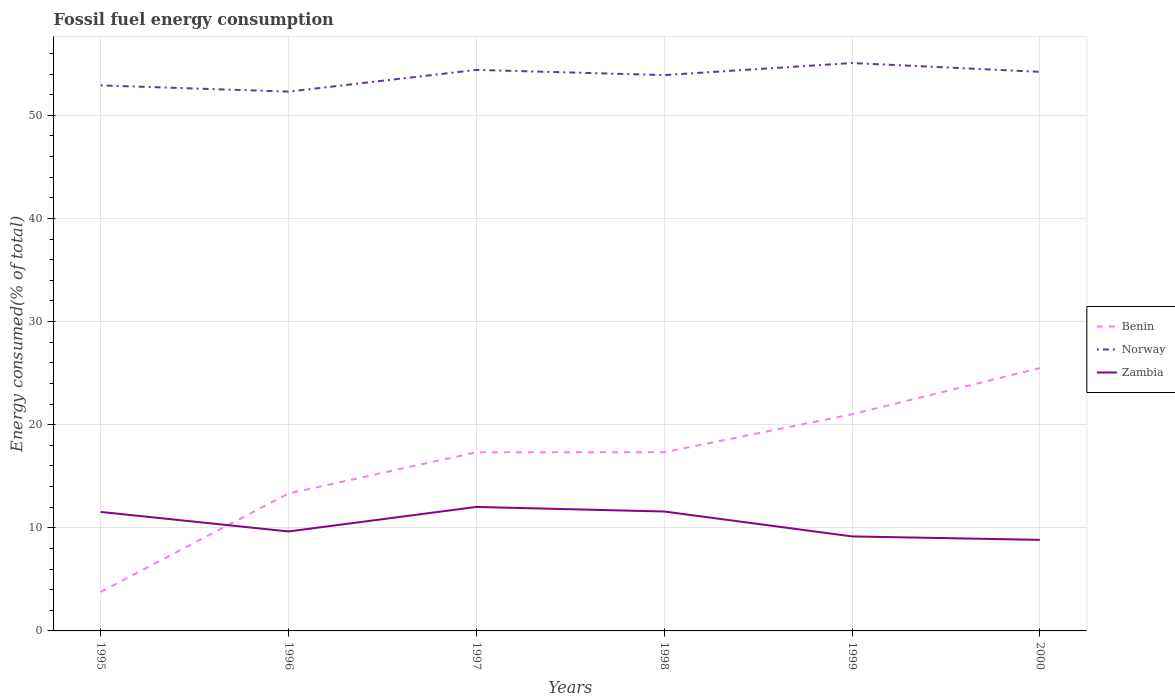Does the line corresponding to Zambia intersect with the line corresponding to Benin?
Make the answer very short. Yes. Is the number of lines equal to the number of legend labels?
Offer a terse response. Yes. Across all years, what is the maximum percentage of energy consumed in Zambia?
Provide a succinct answer. 8.83. In which year was the percentage of energy consumed in Zambia maximum?
Ensure brevity in your answer.  2000. What is the total percentage of energy consumed in Norway in the graph?
Offer a very short reply. 0.6. What is the difference between the highest and the second highest percentage of energy consumed in Norway?
Ensure brevity in your answer.  2.77. What is the difference between the highest and the lowest percentage of energy consumed in Norway?
Your response must be concise. 4. How many lines are there?
Provide a succinct answer. 3. What is the difference between two consecutive major ticks on the Y-axis?
Ensure brevity in your answer.  10. Are the values on the major ticks of Y-axis written in scientific E-notation?
Ensure brevity in your answer.  No. Does the graph contain grids?
Ensure brevity in your answer.  Yes. How many legend labels are there?
Your response must be concise. 3. How are the legend labels stacked?
Keep it short and to the point. Vertical. What is the title of the graph?
Ensure brevity in your answer.  Fossil fuel energy consumption. Does "United Kingdom" appear as one of the legend labels in the graph?
Your answer should be compact. No. What is the label or title of the Y-axis?
Make the answer very short. Energy consumed(% of total). What is the Energy consumed(% of total) of Benin in 1995?
Provide a succinct answer. 3.78. What is the Energy consumed(% of total) in Norway in 1995?
Provide a succinct answer. 52.9. What is the Energy consumed(% of total) in Zambia in 1995?
Give a very brief answer. 11.54. What is the Energy consumed(% of total) of Benin in 1996?
Provide a succinct answer. 13.33. What is the Energy consumed(% of total) in Norway in 1996?
Make the answer very short. 52.3. What is the Energy consumed(% of total) in Zambia in 1996?
Keep it short and to the point. 9.65. What is the Energy consumed(% of total) in Benin in 1997?
Provide a succinct answer. 17.32. What is the Energy consumed(% of total) in Norway in 1997?
Offer a terse response. 54.4. What is the Energy consumed(% of total) in Zambia in 1997?
Provide a succinct answer. 12.02. What is the Energy consumed(% of total) in Benin in 1998?
Provide a short and direct response. 17.33. What is the Energy consumed(% of total) in Norway in 1998?
Keep it short and to the point. 53.9. What is the Energy consumed(% of total) in Zambia in 1998?
Make the answer very short. 11.58. What is the Energy consumed(% of total) in Benin in 1999?
Offer a terse response. 21.01. What is the Energy consumed(% of total) of Norway in 1999?
Offer a terse response. 55.07. What is the Energy consumed(% of total) of Zambia in 1999?
Provide a succinct answer. 9.16. What is the Energy consumed(% of total) in Benin in 2000?
Provide a succinct answer. 25.49. What is the Energy consumed(% of total) in Norway in 2000?
Make the answer very short. 54.22. What is the Energy consumed(% of total) of Zambia in 2000?
Give a very brief answer. 8.83. Across all years, what is the maximum Energy consumed(% of total) in Benin?
Keep it short and to the point. 25.49. Across all years, what is the maximum Energy consumed(% of total) in Norway?
Your answer should be very brief. 55.07. Across all years, what is the maximum Energy consumed(% of total) of Zambia?
Provide a succinct answer. 12.02. Across all years, what is the minimum Energy consumed(% of total) in Benin?
Give a very brief answer. 3.78. Across all years, what is the minimum Energy consumed(% of total) of Norway?
Ensure brevity in your answer.  52.3. Across all years, what is the minimum Energy consumed(% of total) in Zambia?
Give a very brief answer. 8.83. What is the total Energy consumed(% of total) in Benin in the graph?
Make the answer very short. 98.26. What is the total Energy consumed(% of total) of Norway in the graph?
Your answer should be very brief. 322.79. What is the total Energy consumed(% of total) of Zambia in the graph?
Provide a succinct answer. 62.78. What is the difference between the Energy consumed(% of total) in Benin in 1995 and that in 1996?
Your response must be concise. -9.55. What is the difference between the Energy consumed(% of total) of Norway in 1995 and that in 1996?
Provide a succinct answer. 0.6. What is the difference between the Energy consumed(% of total) of Zambia in 1995 and that in 1996?
Your response must be concise. 1.89. What is the difference between the Energy consumed(% of total) of Benin in 1995 and that in 1997?
Your answer should be compact. -13.54. What is the difference between the Energy consumed(% of total) of Norway in 1995 and that in 1997?
Your response must be concise. -1.5. What is the difference between the Energy consumed(% of total) of Zambia in 1995 and that in 1997?
Your answer should be compact. -0.48. What is the difference between the Energy consumed(% of total) in Benin in 1995 and that in 1998?
Make the answer very short. -13.55. What is the difference between the Energy consumed(% of total) of Norway in 1995 and that in 1998?
Your answer should be very brief. -1. What is the difference between the Energy consumed(% of total) of Zambia in 1995 and that in 1998?
Offer a very short reply. -0.04. What is the difference between the Energy consumed(% of total) of Benin in 1995 and that in 1999?
Make the answer very short. -17.23. What is the difference between the Energy consumed(% of total) of Norway in 1995 and that in 1999?
Offer a very short reply. -2.17. What is the difference between the Energy consumed(% of total) in Zambia in 1995 and that in 1999?
Offer a very short reply. 2.37. What is the difference between the Energy consumed(% of total) in Benin in 1995 and that in 2000?
Your answer should be compact. -21.71. What is the difference between the Energy consumed(% of total) of Norway in 1995 and that in 2000?
Provide a succinct answer. -1.31. What is the difference between the Energy consumed(% of total) of Zambia in 1995 and that in 2000?
Offer a terse response. 2.71. What is the difference between the Energy consumed(% of total) of Benin in 1996 and that in 1997?
Provide a succinct answer. -3.99. What is the difference between the Energy consumed(% of total) of Norway in 1996 and that in 1997?
Your response must be concise. -2.11. What is the difference between the Energy consumed(% of total) in Zambia in 1996 and that in 1997?
Provide a succinct answer. -2.38. What is the difference between the Energy consumed(% of total) of Benin in 1996 and that in 1998?
Ensure brevity in your answer.  -4. What is the difference between the Energy consumed(% of total) in Norway in 1996 and that in 1998?
Your answer should be very brief. -1.6. What is the difference between the Energy consumed(% of total) of Zambia in 1996 and that in 1998?
Your answer should be compact. -1.93. What is the difference between the Energy consumed(% of total) of Benin in 1996 and that in 1999?
Offer a very short reply. -7.68. What is the difference between the Energy consumed(% of total) in Norway in 1996 and that in 1999?
Offer a very short reply. -2.77. What is the difference between the Energy consumed(% of total) of Zambia in 1996 and that in 1999?
Your response must be concise. 0.48. What is the difference between the Energy consumed(% of total) in Benin in 1996 and that in 2000?
Offer a terse response. -12.15. What is the difference between the Energy consumed(% of total) in Norway in 1996 and that in 2000?
Give a very brief answer. -1.92. What is the difference between the Energy consumed(% of total) in Zambia in 1996 and that in 2000?
Provide a short and direct response. 0.81. What is the difference between the Energy consumed(% of total) of Benin in 1997 and that in 1998?
Keep it short and to the point. -0.01. What is the difference between the Energy consumed(% of total) in Norway in 1997 and that in 1998?
Your response must be concise. 0.5. What is the difference between the Energy consumed(% of total) in Zambia in 1997 and that in 1998?
Your answer should be compact. 0.44. What is the difference between the Energy consumed(% of total) of Benin in 1997 and that in 1999?
Keep it short and to the point. -3.69. What is the difference between the Energy consumed(% of total) in Norway in 1997 and that in 1999?
Offer a terse response. -0.67. What is the difference between the Energy consumed(% of total) in Zambia in 1997 and that in 1999?
Make the answer very short. 2.86. What is the difference between the Energy consumed(% of total) of Benin in 1997 and that in 2000?
Give a very brief answer. -8.16. What is the difference between the Energy consumed(% of total) in Norway in 1997 and that in 2000?
Provide a succinct answer. 0.19. What is the difference between the Energy consumed(% of total) in Zambia in 1997 and that in 2000?
Your response must be concise. 3.19. What is the difference between the Energy consumed(% of total) in Benin in 1998 and that in 1999?
Provide a succinct answer. -3.68. What is the difference between the Energy consumed(% of total) in Norway in 1998 and that in 1999?
Give a very brief answer. -1.17. What is the difference between the Energy consumed(% of total) in Zambia in 1998 and that in 1999?
Your response must be concise. 2.41. What is the difference between the Energy consumed(% of total) of Benin in 1998 and that in 2000?
Your response must be concise. -8.16. What is the difference between the Energy consumed(% of total) in Norway in 1998 and that in 2000?
Offer a very short reply. -0.31. What is the difference between the Energy consumed(% of total) in Zambia in 1998 and that in 2000?
Offer a very short reply. 2.75. What is the difference between the Energy consumed(% of total) of Benin in 1999 and that in 2000?
Provide a succinct answer. -4.48. What is the difference between the Energy consumed(% of total) of Norway in 1999 and that in 2000?
Your answer should be compact. 0.85. What is the difference between the Energy consumed(% of total) of Zambia in 1999 and that in 2000?
Make the answer very short. 0.33. What is the difference between the Energy consumed(% of total) in Benin in 1995 and the Energy consumed(% of total) in Norway in 1996?
Your response must be concise. -48.52. What is the difference between the Energy consumed(% of total) in Benin in 1995 and the Energy consumed(% of total) in Zambia in 1996?
Your answer should be compact. -5.86. What is the difference between the Energy consumed(% of total) of Norway in 1995 and the Energy consumed(% of total) of Zambia in 1996?
Ensure brevity in your answer.  43.26. What is the difference between the Energy consumed(% of total) of Benin in 1995 and the Energy consumed(% of total) of Norway in 1997?
Provide a short and direct response. -50.62. What is the difference between the Energy consumed(% of total) in Benin in 1995 and the Energy consumed(% of total) in Zambia in 1997?
Provide a succinct answer. -8.24. What is the difference between the Energy consumed(% of total) in Norway in 1995 and the Energy consumed(% of total) in Zambia in 1997?
Ensure brevity in your answer.  40.88. What is the difference between the Energy consumed(% of total) of Benin in 1995 and the Energy consumed(% of total) of Norway in 1998?
Keep it short and to the point. -50.12. What is the difference between the Energy consumed(% of total) of Benin in 1995 and the Energy consumed(% of total) of Zambia in 1998?
Your answer should be very brief. -7.8. What is the difference between the Energy consumed(% of total) of Norway in 1995 and the Energy consumed(% of total) of Zambia in 1998?
Your answer should be compact. 41.32. What is the difference between the Energy consumed(% of total) in Benin in 1995 and the Energy consumed(% of total) in Norway in 1999?
Your answer should be very brief. -51.29. What is the difference between the Energy consumed(% of total) in Benin in 1995 and the Energy consumed(% of total) in Zambia in 1999?
Your response must be concise. -5.38. What is the difference between the Energy consumed(% of total) in Norway in 1995 and the Energy consumed(% of total) in Zambia in 1999?
Offer a terse response. 43.74. What is the difference between the Energy consumed(% of total) of Benin in 1995 and the Energy consumed(% of total) of Norway in 2000?
Offer a very short reply. -50.44. What is the difference between the Energy consumed(% of total) of Benin in 1995 and the Energy consumed(% of total) of Zambia in 2000?
Give a very brief answer. -5.05. What is the difference between the Energy consumed(% of total) in Norway in 1995 and the Energy consumed(% of total) in Zambia in 2000?
Your answer should be compact. 44.07. What is the difference between the Energy consumed(% of total) in Benin in 1996 and the Energy consumed(% of total) in Norway in 1997?
Make the answer very short. -41.07. What is the difference between the Energy consumed(% of total) of Benin in 1996 and the Energy consumed(% of total) of Zambia in 1997?
Offer a very short reply. 1.31. What is the difference between the Energy consumed(% of total) in Norway in 1996 and the Energy consumed(% of total) in Zambia in 1997?
Ensure brevity in your answer.  40.28. What is the difference between the Energy consumed(% of total) of Benin in 1996 and the Energy consumed(% of total) of Norway in 1998?
Your answer should be very brief. -40.57. What is the difference between the Energy consumed(% of total) in Benin in 1996 and the Energy consumed(% of total) in Zambia in 1998?
Your answer should be very brief. 1.75. What is the difference between the Energy consumed(% of total) in Norway in 1996 and the Energy consumed(% of total) in Zambia in 1998?
Make the answer very short. 40.72. What is the difference between the Energy consumed(% of total) of Benin in 1996 and the Energy consumed(% of total) of Norway in 1999?
Make the answer very short. -41.74. What is the difference between the Energy consumed(% of total) of Benin in 1996 and the Energy consumed(% of total) of Zambia in 1999?
Keep it short and to the point. 4.17. What is the difference between the Energy consumed(% of total) of Norway in 1996 and the Energy consumed(% of total) of Zambia in 1999?
Your answer should be very brief. 43.13. What is the difference between the Energy consumed(% of total) in Benin in 1996 and the Energy consumed(% of total) in Norway in 2000?
Your answer should be very brief. -40.88. What is the difference between the Energy consumed(% of total) in Benin in 1996 and the Energy consumed(% of total) in Zambia in 2000?
Your response must be concise. 4.5. What is the difference between the Energy consumed(% of total) in Norway in 1996 and the Energy consumed(% of total) in Zambia in 2000?
Your answer should be compact. 43.47. What is the difference between the Energy consumed(% of total) of Benin in 1997 and the Energy consumed(% of total) of Norway in 1998?
Make the answer very short. -36.58. What is the difference between the Energy consumed(% of total) of Benin in 1997 and the Energy consumed(% of total) of Zambia in 1998?
Your answer should be compact. 5.74. What is the difference between the Energy consumed(% of total) of Norway in 1997 and the Energy consumed(% of total) of Zambia in 1998?
Ensure brevity in your answer.  42.82. What is the difference between the Energy consumed(% of total) in Benin in 1997 and the Energy consumed(% of total) in Norway in 1999?
Ensure brevity in your answer.  -37.75. What is the difference between the Energy consumed(% of total) in Benin in 1997 and the Energy consumed(% of total) in Zambia in 1999?
Your answer should be compact. 8.16. What is the difference between the Energy consumed(% of total) in Norway in 1997 and the Energy consumed(% of total) in Zambia in 1999?
Ensure brevity in your answer.  45.24. What is the difference between the Energy consumed(% of total) in Benin in 1997 and the Energy consumed(% of total) in Norway in 2000?
Provide a succinct answer. -36.89. What is the difference between the Energy consumed(% of total) of Benin in 1997 and the Energy consumed(% of total) of Zambia in 2000?
Your response must be concise. 8.49. What is the difference between the Energy consumed(% of total) in Norway in 1997 and the Energy consumed(% of total) in Zambia in 2000?
Make the answer very short. 45.57. What is the difference between the Energy consumed(% of total) of Benin in 1998 and the Energy consumed(% of total) of Norway in 1999?
Provide a succinct answer. -37.74. What is the difference between the Energy consumed(% of total) in Benin in 1998 and the Energy consumed(% of total) in Zambia in 1999?
Give a very brief answer. 8.17. What is the difference between the Energy consumed(% of total) of Norway in 1998 and the Energy consumed(% of total) of Zambia in 1999?
Your response must be concise. 44.74. What is the difference between the Energy consumed(% of total) of Benin in 1998 and the Energy consumed(% of total) of Norway in 2000?
Offer a terse response. -36.89. What is the difference between the Energy consumed(% of total) in Benin in 1998 and the Energy consumed(% of total) in Zambia in 2000?
Provide a succinct answer. 8.5. What is the difference between the Energy consumed(% of total) of Norway in 1998 and the Energy consumed(% of total) of Zambia in 2000?
Provide a short and direct response. 45.07. What is the difference between the Energy consumed(% of total) in Benin in 1999 and the Energy consumed(% of total) in Norway in 2000?
Your response must be concise. -33.21. What is the difference between the Energy consumed(% of total) of Benin in 1999 and the Energy consumed(% of total) of Zambia in 2000?
Your answer should be compact. 12.18. What is the difference between the Energy consumed(% of total) in Norway in 1999 and the Energy consumed(% of total) in Zambia in 2000?
Your response must be concise. 46.24. What is the average Energy consumed(% of total) of Benin per year?
Give a very brief answer. 16.38. What is the average Energy consumed(% of total) in Norway per year?
Provide a succinct answer. 53.8. What is the average Energy consumed(% of total) in Zambia per year?
Give a very brief answer. 10.46. In the year 1995, what is the difference between the Energy consumed(% of total) of Benin and Energy consumed(% of total) of Norway?
Your answer should be very brief. -49.12. In the year 1995, what is the difference between the Energy consumed(% of total) of Benin and Energy consumed(% of total) of Zambia?
Keep it short and to the point. -7.76. In the year 1995, what is the difference between the Energy consumed(% of total) in Norway and Energy consumed(% of total) in Zambia?
Your answer should be compact. 41.36. In the year 1996, what is the difference between the Energy consumed(% of total) in Benin and Energy consumed(% of total) in Norway?
Offer a terse response. -38.97. In the year 1996, what is the difference between the Energy consumed(% of total) in Benin and Energy consumed(% of total) in Zambia?
Ensure brevity in your answer.  3.69. In the year 1996, what is the difference between the Energy consumed(% of total) of Norway and Energy consumed(% of total) of Zambia?
Your response must be concise. 42.65. In the year 1997, what is the difference between the Energy consumed(% of total) of Benin and Energy consumed(% of total) of Norway?
Ensure brevity in your answer.  -37.08. In the year 1997, what is the difference between the Energy consumed(% of total) of Benin and Energy consumed(% of total) of Zambia?
Offer a very short reply. 5.3. In the year 1997, what is the difference between the Energy consumed(% of total) in Norway and Energy consumed(% of total) in Zambia?
Keep it short and to the point. 42.38. In the year 1998, what is the difference between the Energy consumed(% of total) of Benin and Energy consumed(% of total) of Norway?
Offer a terse response. -36.57. In the year 1998, what is the difference between the Energy consumed(% of total) of Benin and Energy consumed(% of total) of Zambia?
Your answer should be very brief. 5.75. In the year 1998, what is the difference between the Energy consumed(% of total) in Norway and Energy consumed(% of total) in Zambia?
Offer a terse response. 42.32. In the year 1999, what is the difference between the Energy consumed(% of total) of Benin and Energy consumed(% of total) of Norway?
Offer a very short reply. -34.06. In the year 1999, what is the difference between the Energy consumed(% of total) of Benin and Energy consumed(% of total) of Zambia?
Provide a succinct answer. 11.84. In the year 1999, what is the difference between the Energy consumed(% of total) in Norway and Energy consumed(% of total) in Zambia?
Your answer should be compact. 45.91. In the year 2000, what is the difference between the Energy consumed(% of total) of Benin and Energy consumed(% of total) of Norway?
Ensure brevity in your answer.  -28.73. In the year 2000, what is the difference between the Energy consumed(% of total) of Benin and Energy consumed(% of total) of Zambia?
Your response must be concise. 16.66. In the year 2000, what is the difference between the Energy consumed(% of total) in Norway and Energy consumed(% of total) in Zambia?
Your answer should be compact. 45.39. What is the ratio of the Energy consumed(% of total) of Benin in 1995 to that in 1996?
Your answer should be very brief. 0.28. What is the ratio of the Energy consumed(% of total) in Norway in 1995 to that in 1996?
Give a very brief answer. 1.01. What is the ratio of the Energy consumed(% of total) in Zambia in 1995 to that in 1996?
Give a very brief answer. 1.2. What is the ratio of the Energy consumed(% of total) in Benin in 1995 to that in 1997?
Provide a short and direct response. 0.22. What is the ratio of the Energy consumed(% of total) in Norway in 1995 to that in 1997?
Provide a succinct answer. 0.97. What is the ratio of the Energy consumed(% of total) of Zambia in 1995 to that in 1997?
Give a very brief answer. 0.96. What is the ratio of the Energy consumed(% of total) in Benin in 1995 to that in 1998?
Offer a very short reply. 0.22. What is the ratio of the Energy consumed(% of total) of Norway in 1995 to that in 1998?
Your answer should be compact. 0.98. What is the ratio of the Energy consumed(% of total) of Benin in 1995 to that in 1999?
Make the answer very short. 0.18. What is the ratio of the Energy consumed(% of total) in Norway in 1995 to that in 1999?
Provide a short and direct response. 0.96. What is the ratio of the Energy consumed(% of total) of Zambia in 1995 to that in 1999?
Your response must be concise. 1.26. What is the ratio of the Energy consumed(% of total) of Benin in 1995 to that in 2000?
Make the answer very short. 0.15. What is the ratio of the Energy consumed(% of total) of Norway in 1995 to that in 2000?
Your answer should be very brief. 0.98. What is the ratio of the Energy consumed(% of total) of Zambia in 1995 to that in 2000?
Give a very brief answer. 1.31. What is the ratio of the Energy consumed(% of total) of Benin in 1996 to that in 1997?
Offer a terse response. 0.77. What is the ratio of the Energy consumed(% of total) of Norway in 1996 to that in 1997?
Your answer should be very brief. 0.96. What is the ratio of the Energy consumed(% of total) in Zambia in 1996 to that in 1997?
Offer a terse response. 0.8. What is the ratio of the Energy consumed(% of total) of Benin in 1996 to that in 1998?
Your answer should be very brief. 0.77. What is the ratio of the Energy consumed(% of total) in Norway in 1996 to that in 1998?
Provide a succinct answer. 0.97. What is the ratio of the Energy consumed(% of total) in Zambia in 1996 to that in 1998?
Your answer should be very brief. 0.83. What is the ratio of the Energy consumed(% of total) in Benin in 1996 to that in 1999?
Offer a very short reply. 0.63. What is the ratio of the Energy consumed(% of total) in Norway in 1996 to that in 1999?
Your answer should be very brief. 0.95. What is the ratio of the Energy consumed(% of total) of Zambia in 1996 to that in 1999?
Offer a terse response. 1.05. What is the ratio of the Energy consumed(% of total) in Benin in 1996 to that in 2000?
Keep it short and to the point. 0.52. What is the ratio of the Energy consumed(% of total) of Norway in 1996 to that in 2000?
Your answer should be very brief. 0.96. What is the ratio of the Energy consumed(% of total) in Zambia in 1996 to that in 2000?
Your answer should be compact. 1.09. What is the ratio of the Energy consumed(% of total) in Benin in 1997 to that in 1998?
Keep it short and to the point. 1. What is the ratio of the Energy consumed(% of total) in Norway in 1997 to that in 1998?
Make the answer very short. 1.01. What is the ratio of the Energy consumed(% of total) in Zambia in 1997 to that in 1998?
Your response must be concise. 1.04. What is the ratio of the Energy consumed(% of total) in Benin in 1997 to that in 1999?
Keep it short and to the point. 0.82. What is the ratio of the Energy consumed(% of total) of Norway in 1997 to that in 1999?
Offer a terse response. 0.99. What is the ratio of the Energy consumed(% of total) of Zambia in 1997 to that in 1999?
Offer a very short reply. 1.31. What is the ratio of the Energy consumed(% of total) in Benin in 1997 to that in 2000?
Provide a short and direct response. 0.68. What is the ratio of the Energy consumed(% of total) of Norway in 1997 to that in 2000?
Your answer should be compact. 1. What is the ratio of the Energy consumed(% of total) in Zambia in 1997 to that in 2000?
Make the answer very short. 1.36. What is the ratio of the Energy consumed(% of total) of Benin in 1998 to that in 1999?
Offer a terse response. 0.82. What is the ratio of the Energy consumed(% of total) in Norway in 1998 to that in 1999?
Ensure brevity in your answer.  0.98. What is the ratio of the Energy consumed(% of total) of Zambia in 1998 to that in 1999?
Your answer should be very brief. 1.26. What is the ratio of the Energy consumed(% of total) in Benin in 1998 to that in 2000?
Your answer should be compact. 0.68. What is the ratio of the Energy consumed(% of total) of Norway in 1998 to that in 2000?
Ensure brevity in your answer.  0.99. What is the ratio of the Energy consumed(% of total) in Zambia in 1998 to that in 2000?
Provide a short and direct response. 1.31. What is the ratio of the Energy consumed(% of total) in Benin in 1999 to that in 2000?
Provide a short and direct response. 0.82. What is the ratio of the Energy consumed(% of total) of Norway in 1999 to that in 2000?
Make the answer very short. 1.02. What is the ratio of the Energy consumed(% of total) in Zambia in 1999 to that in 2000?
Give a very brief answer. 1.04. What is the difference between the highest and the second highest Energy consumed(% of total) in Benin?
Provide a succinct answer. 4.48. What is the difference between the highest and the second highest Energy consumed(% of total) of Norway?
Offer a very short reply. 0.67. What is the difference between the highest and the second highest Energy consumed(% of total) of Zambia?
Your answer should be compact. 0.44. What is the difference between the highest and the lowest Energy consumed(% of total) of Benin?
Your response must be concise. 21.71. What is the difference between the highest and the lowest Energy consumed(% of total) of Norway?
Keep it short and to the point. 2.77. What is the difference between the highest and the lowest Energy consumed(% of total) in Zambia?
Make the answer very short. 3.19. 